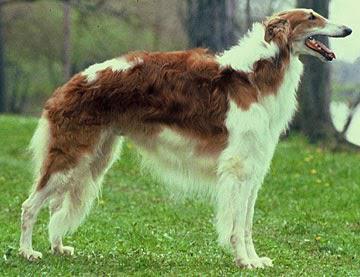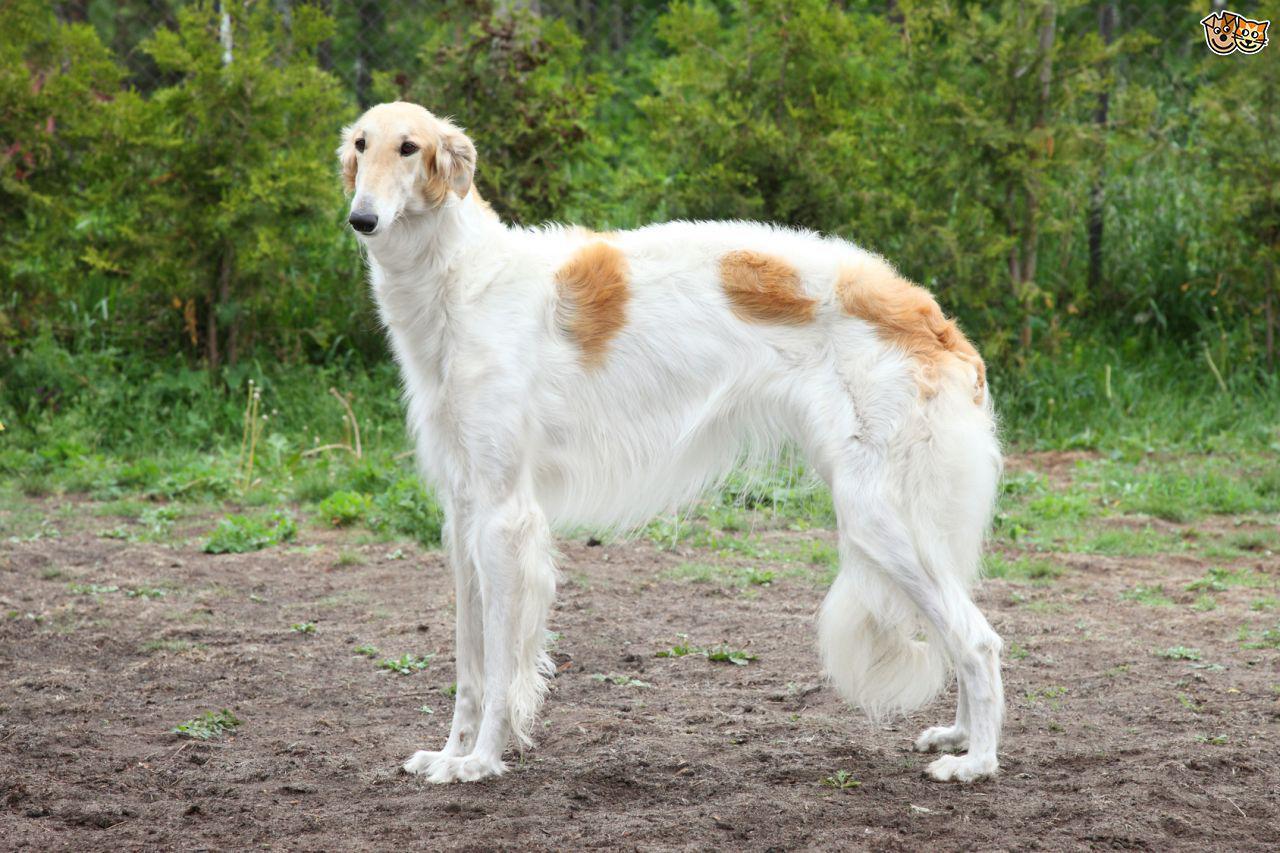The first image is the image on the left, the second image is the image on the right. Considering the images on both sides, is "Exactly three dogs are shown in grassy outdoor settings." valid? Answer yes or no. No. 